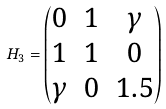<formula> <loc_0><loc_0><loc_500><loc_500>H _ { 3 } = \begin{pmatrix} 0 & 1 & \gamma \\ 1 & 1 & 0 \\ \gamma & 0 & 1 . 5 \end{pmatrix}</formula> 